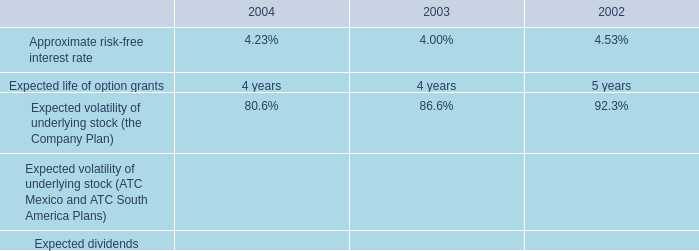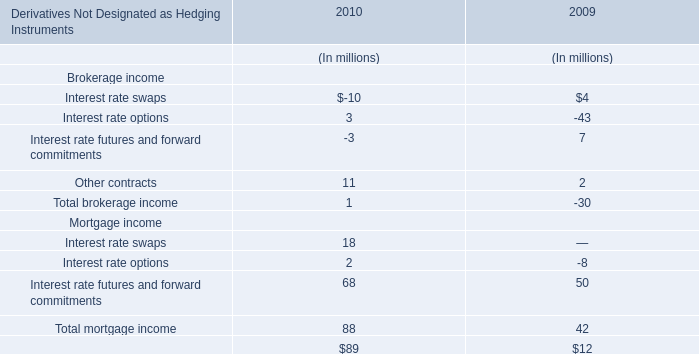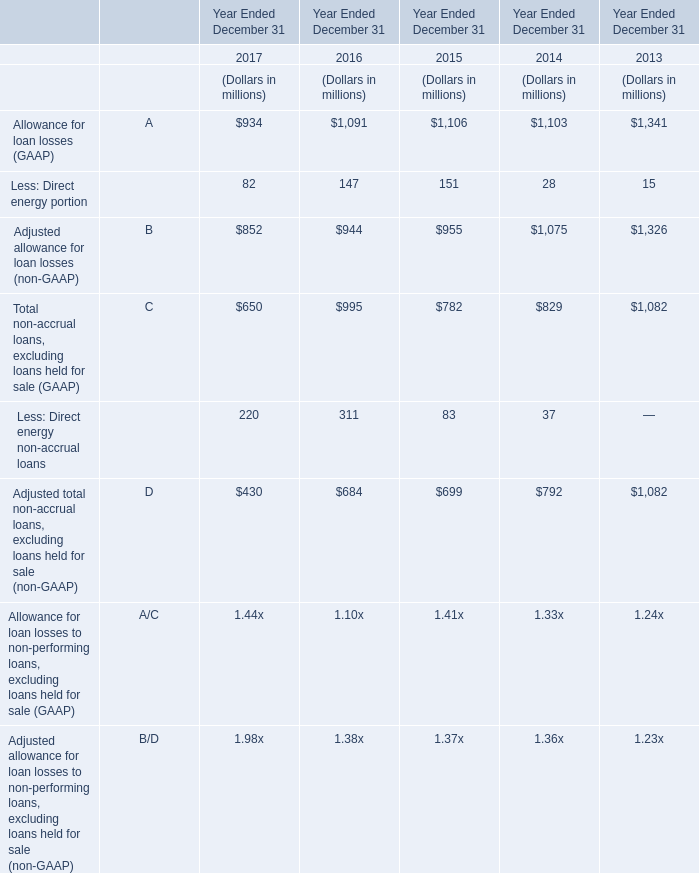what is the growth rate in weighted average fair values of the company 2019s options granted from 2003 to 2004? 
Computations: ((7.05 - 6.32) / 6.32)
Answer: 0.11551. 